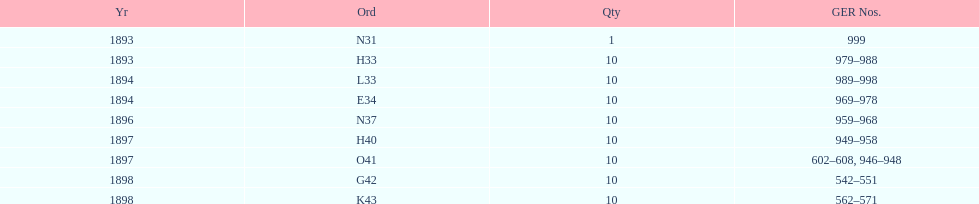Which order was the next order after l33? E34. 